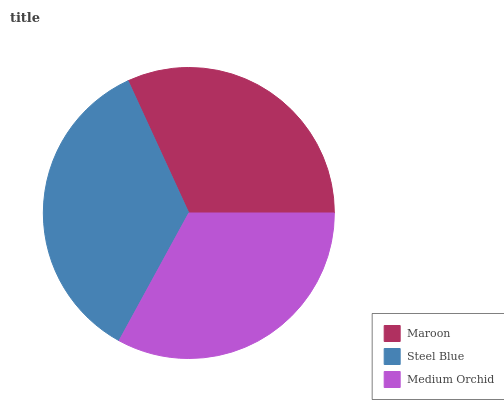Is Maroon the minimum?
Answer yes or no. Yes. Is Steel Blue the maximum?
Answer yes or no. Yes. Is Medium Orchid the minimum?
Answer yes or no. No. Is Medium Orchid the maximum?
Answer yes or no. No. Is Steel Blue greater than Medium Orchid?
Answer yes or no. Yes. Is Medium Orchid less than Steel Blue?
Answer yes or no. Yes. Is Medium Orchid greater than Steel Blue?
Answer yes or no. No. Is Steel Blue less than Medium Orchid?
Answer yes or no. No. Is Medium Orchid the high median?
Answer yes or no. Yes. Is Medium Orchid the low median?
Answer yes or no. Yes. Is Steel Blue the high median?
Answer yes or no. No. Is Maroon the low median?
Answer yes or no. No. 